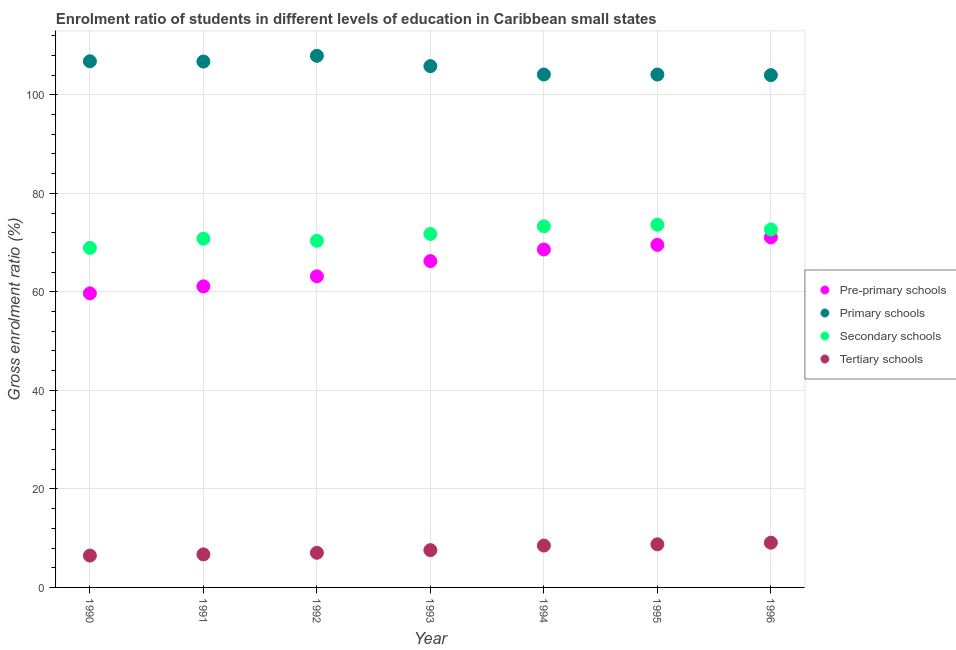Is the number of dotlines equal to the number of legend labels?
Your response must be concise. Yes. What is the gross enrolment ratio in primary schools in 1992?
Your response must be concise. 107.91. Across all years, what is the maximum gross enrolment ratio in tertiary schools?
Keep it short and to the point. 9.08. Across all years, what is the minimum gross enrolment ratio in pre-primary schools?
Your answer should be compact. 59.69. What is the total gross enrolment ratio in tertiary schools in the graph?
Give a very brief answer. 54.09. What is the difference between the gross enrolment ratio in tertiary schools in 1994 and that in 1995?
Make the answer very short. -0.26. What is the difference between the gross enrolment ratio in primary schools in 1990 and the gross enrolment ratio in secondary schools in 1993?
Provide a succinct answer. 35.05. What is the average gross enrolment ratio in pre-primary schools per year?
Offer a terse response. 65.63. In the year 1991, what is the difference between the gross enrolment ratio in pre-primary schools and gross enrolment ratio in primary schools?
Your answer should be compact. -45.63. In how many years, is the gross enrolment ratio in tertiary schools greater than 52 %?
Provide a succinct answer. 0. What is the ratio of the gross enrolment ratio in tertiary schools in 1990 to that in 1996?
Make the answer very short. 0.71. Is the difference between the gross enrolment ratio in pre-primary schools in 1993 and 1996 greater than the difference between the gross enrolment ratio in tertiary schools in 1993 and 1996?
Your answer should be very brief. No. What is the difference between the highest and the second highest gross enrolment ratio in pre-primary schools?
Ensure brevity in your answer.  1.51. What is the difference between the highest and the lowest gross enrolment ratio in tertiary schools?
Your answer should be compact. 2.62. In how many years, is the gross enrolment ratio in pre-primary schools greater than the average gross enrolment ratio in pre-primary schools taken over all years?
Ensure brevity in your answer.  4. Is it the case that in every year, the sum of the gross enrolment ratio in pre-primary schools and gross enrolment ratio in primary schools is greater than the gross enrolment ratio in secondary schools?
Your response must be concise. Yes. Is the gross enrolment ratio in tertiary schools strictly greater than the gross enrolment ratio in secondary schools over the years?
Offer a terse response. No. How many dotlines are there?
Your response must be concise. 4. How many years are there in the graph?
Offer a terse response. 7. Does the graph contain any zero values?
Your answer should be very brief. No. What is the title of the graph?
Make the answer very short. Enrolment ratio of students in different levels of education in Caribbean small states. Does "Switzerland" appear as one of the legend labels in the graph?
Keep it short and to the point. No. What is the label or title of the Y-axis?
Keep it short and to the point. Gross enrolment ratio (%). What is the Gross enrolment ratio (%) of Pre-primary schools in 1990?
Offer a terse response. 59.69. What is the Gross enrolment ratio (%) of Primary schools in 1990?
Your response must be concise. 106.8. What is the Gross enrolment ratio (%) in Secondary schools in 1990?
Your response must be concise. 68.92. What is the Gross enrolment ratio (%) of Tertiary schools in 1990?
Offer a very short reply. 6.46. What is the Gross enrolment ratio (%) of Pre-primary schools in 1991?
Ensure brevity in your answer.  61.12. What is the Gross enrolment ratio (%) in Primary schools in 1991?
Your answer should be very brief. 106.75. What is the Gross enrolment ratio (%) in Secondary schools in 1991?
Make the answer very short. 70.79. What is the Gross enrolment ratio (%) of Tertiary schools in 1991?
Ensure brevity in your answer.  6.71. What is the Gross enrolment ratio (%) of Pre-primary schools in 1992?
Give a very brief answer. 63.15. What is the Gross enrolment ratio (%) of Primary schools in 1992?
Provide a short and direct response. 107.91. What is the Gross enrolment ratio (%) in Secondary schools in 1992?
Offer a very short reply. 70.37. What is the Gross enrolment ratio (%) in Tertiary schools in 1992?
Make the answer very short. 7.03. What is the Gross enrolment ratio (%) of Pre-primary schools in 1993?
Keep it short and to the point. 66.24. What is the Gross enrolment ratio (%) of Primary schools in 1993?
Provide a succinct answer. 105.81. What is the Gross enrolment ratio (%) of Secondary schools in 1993?
Offer a terse response. 71.75. What is the Gross enrolment ratio (%) in Tertiary schools in 1993?
Make the answer very short. 7.57. What is the Gross enrolment ratio (%) in Pre-primary schools in 1994?
Offer a terse response. 68.6. What is the Gross enrolment ratio (%) of Primary schools in 1994?
Give a very brief answer. 104.12. What is the Gross enrolment ratio (%) in Secondary schools in 1994?
Ensure brevity in your answer.  73.3. What is the Gross enrolment ratio (%) in Tertiary schools in 1994?
Ensure brevity in your answer.  8.5. What is the Gross enrolment ratio (%) of Pre-primary schools in 1995?
Provide a short and direct response. 69.53. What is the Gross enrolment ratio (%) of Primary schools in 1995?
Provide a succinct answer. 104.11. What is the Gross enrolment ratio (%) in Secondary schools in 1995?
Your answer should be very brief. 73.62. What is the Gross enrolment ratio (%) of Tertiary schools in 1995?
Your answer should be very brief. 8.75. What is the Gross enrolment ratio (%) in Pre-primary schools in 1996?
Offer a very short reply. 71.05. What is the Gross enrolment ratio (%) in Primary schools in 1996?
Provide a short and direct response. 103.98. What is the Gross enrolment ratio (%) in Secondary schools in 1996?
Offer a terse response. 72.66. What is the Gross enrolment ratio (%) of Tertiary schools in 1996?
Give a very brief answer. 9.08. Across all years, what is the maximum Gross enrolment ratio (%) in Pre-primary schools?
Your answer should be compact. 71.05. Across all years, what is the maximum Gross enrolment ratio (%) in Primary schools?
Make the answer very short. 107.91. Across all years, what is the maximum Gross enrolment ratio (%) of Secondary schools?
Give a very brief answer. 73.62. Across all years, what is the maximum Gross enrolment ratio (%) of Tertiary schools?
Make the answer very short. 9.08. Across all years, what is the minimum Gross enrolment ratio (%) of Pre-primary schools?
Make the answer very short. 59.69. Across all years, what is the minimum Gross enrolment ratio (%) in Primary schools?
Your answer should be very brief. 103.98. Across all years, what is the minimum Gross enrolment ratio (%) in Secondary schools?
Your response must be concise. 68.92. Across all years, what is the minimum Gross enrolment ratio (%) in Tertiary schools?
Provide a succinct answer. 6.46. What is the total Gross enrolment ratio (%) of Pre-primary schools in the graph?
Provide a succinct answer. 459.38. What is the total Gross enrolment ratio (%) of Primary schools in the graph?
Ensure brevity in your answer.  739.47. What is the total Gross enrolment ratio (%) of Secondary schools in the graph?
Offer a very short reply. 501.4. What is the total Gross enrolment ratio (%) in Tertiary schools in the graph?
Your answer should be very brief. 54.09. What is the difference between the Gross enrolment ratio (%) in Pre-primary schools in 1990 and that in 1991?
Your answer should be very brief. -1.42. What is the difference between the Gross enrolment ratio (%) in Primary schools in 1990 and that in 1991?
Offer a terse response. 0.05. What is the difference between the Gross enrolment ratio (%) in Secondary schools in 1990 and that in 1991?
Your answer should be compact. -1.87. What is the difference between the Gross enrolment ratio (%) of Tertiary schools in 1990 and that in 1991?
Offer a terse response. -0.24. What is the difference between the Gross enrolment ratio (%) of Pre-primary schools in 1990 and that in 1992?
Offer a terse response. -3.46. What is the difference between the Gross enrolment ratio (%) in Primary schools in 1990 and that in 1992?
Your answer should be very brief. -1.11. What is the difference between the Gross enrolment ratio (%) of Secondary schools in 1990 and that in 1992?
Make the answer very short. -1.45. What is the difference between the Gross enrolment ratio (%) of Tertiary schools in 1990 and that in 1992?
Ensure brevity in your answer.  -0.57. What is the difference between the Gross enrolment ratio (%) of Pre-primary schools in 1990 and that in 1993?
Your answer should be compact. -6.55. What is the difference between the Gross enrolment ratio (%) of Secondary schools in 1990 and that in 1993?
Provide a succinct answer. -2.83. What is the difference between the Gross enrolment ratio (%) of Tertiary schools in 1990 and that in 1993?
Provide a succinct answer. -1.1. What is the difference between the Gross enrolment ratio (%) of Pre-primary schools in 1990 and that in 1994?
Provide a succinct answer. -8.91. What is the difference between the Gross enrolment ratio (%) in Primary schools in 1990 and that in 1994?
Keep it short and to the point. 2.68. What is the difference between the Gross enrolment ratio (%) of Secondary schools in 1990 and that in 1994?
Provide a succinct answer. -4.38. What is the difference between the Gross enrolment ratio (%) in Tertiary schools in 1990 and that in 1994?
Give a very brief answer. -2.03. What is the difference between the Gross enrolment ratio (%) of Pre-primary schools in 1990 and that in 1995?
Give a very brief answer. -9.84. What is the difference between the Gross enrolment ratio (%) of Primary schools in 1990 and that in 1995?
Keep it short and to the point. 2.69. What is the difference between the Gross enrolment ratio (%) of Secondary schools in 1990 and that in 1995?
Make the answer very short. -4.71. What is the difference between the Gross enrolment ratio (%) of Tertiary schools in 1990 and that in 1995?
Your answer should be very brief. -2.29. What is the difference between the Gross enrolment ratio (%) in Pre-primary schools in 1990 and that in 1996?
Your response must be concise. -11.36. What is the difference between the Gross enrolment ratio (%) of Primary schools in 1990 and that in 1996?
Your answer should be very brief. 2.82. What is the difference between the Gross enrolment ratio (%) in Secondary schools in 1990 and that in 1996?
Give a very brief answer. -3.74. What is the difference between the Gross enrolment ratio (%) of Tertiary schools in 1990 and that in 1996?
Your answer should be compact. -2.62. What is the difference between the Gross enrolment ratio (%) of Pre-primary schools in 1991 and that in 1992?
Offer a terse response. -2.04. What is the difference between the Gross enrolment ratio (%) in Primary schools in 1991 and that in 1992?
Provide a short and direct response. -1.16. What is the difference between the Gross enrolment ratio (%) of Secondary schools in 1991 and that in 1992?
Provide a short and direct response. 0.42. What is the difference between the Gross enrolment ratio (%) in Tertiary schools in 1991 and that in 1992?
Provide a short and direct response. -0.32. What is the difference between the Gross enrolment ratio (%) of Pre-primary schools in 1991 and that in 1993?
Provide a short and direct response. -5.13. What is the difference between the Gross enrolment ratio (%) of Primary schools in 1991 and that in 1993?
Your answer should be very brief. 0.93. What is the difference between the Gross enrolment ratio (%) in Secondary schools in 1991 and that in 1993?
Your response must be concise. -0.96. What is the difference between the Gross enrolment ratio (%) of Tertiary schools in 1991 and that in 1993?
Give a very brief answer. -0.86. What is the difference between the Gross enrolment ratio (%) of Pre-primary schools in 1991 and that in 1994?
Give a very brief answer. -7.48. What is the difference between the Gross enrolment ratio (%) of Primary schools in 1991 and that in 1994?
Make the answer very short. 2.63. What is the difference between the Gross enrolment ratio (%) in Secondary schools in 1991 and that in 1994?
Your answer should be compact. -2.51. What is the difference between the Gross enrolment ratio (%) in Tertiary schools in 1991 and that in 1994?
Provide a short and direct response. -1.79. What is the difference between the Gross enrolment ratio (%) of Pre-primary schools in 1991 and that in 1995?
Give a very brief answer. -8.42. What is the difference between the Gross enrolment ratio (%) of Primary schools in 1991 and that in 1995?
Offer a terse response. 2.64. What is the difference between the Gross enrolment ratio (%) of Secondary schools in 1991 and that in 1995?
Offer a very short reply. -2.83. What is the difference between the Gross enrolment ratio (%) of Tertiary schools in 1991 and that in 1995?
Ensure brevity in your answer.  -2.05. What is the difference between the Gross enrolment ratio (%) in Pre-primary schools in 1991 and that in 1996?
Offer a terse response. -9.93. What is the difference between the Gross enrolment ratio (%) of Primary schools in 1991 and that in 1996?
Make the answer very short. 2.76. What is the difference between the Gross enrolment ratio (%) of Secondary schools in 1991 and that in 1996?
Give a very brief answer. -1.87. What is the difference between the Gross enrolment ratio (%) of Tertiary schools in 1991 and that in 1996?
Keep it short and to the point. -2.37. What is the difference between the Gross enrolment ratio (%) in Pre-primary schools in 1992 and that in 1993?
Give a very brief answer. -3.09. What is the difference between the Gross enrolment ratio (%) in Primary schools in 1992 and that in 1993?
Make the answer very short. 2.09. What is the difference between the Gross enrolment ratio (%) of Secondary schools in 1992 and that in 1993?
Your answer should be very brief. -1.38. What is the difference between the Gross enrolment ratio (%) of Tertiary schools in 1992 and that in 1993?
Make the answer very short. -0.54. What is the difference between the Gross enrolment ratio (%) of Pre-primary schools in 1992 and that in 1994?
Ensure brevity in your answer.  -5.45. What is the difference between the Gross enrolment ratio (%) in Primary schools in 1992 and that in 1994?
Provide a short and direct response. 3.79. What is the difference between the Gross enrolment ratio (%) in Secondary schools in 1992 and that in 1994?
Offer a very short reply. -2.93. What is the difference between the Gross enrolment ratio (%) of Tertiary schools in 1992 and that in 1994?
Provide a succinct answer. -1.47. What is the difference between the Gross enrolment ratio (%) of Pre-primary schools in 1992 and that in 1995?
Your answer should be compact. -6.38. What is the difference between the Gross enrolment ratio (%) in Primary schools in 1992 and that in 1995?
Provide a short and direct response. 3.8. What is the difference between the Gross enrolment ratio (%) in Secondary schools in 1992 and that in 1995?
Your response must be concise. -3.26. What is the difference between the Gross enrolment ratio (%) of Tertiary schools in 1992 and that in 1995?
Your answer should be compact. -1.72. What is the difference between the Gross enrolment ratio (%) of Pre-primary schools in 1992 and that in 1996?
Your response must be concise. -7.9. What is the difference between the Gross enrolment ratio (%) in Primary schools in 1992 and that in 1996?
Give a very brief answer. 3.93. What is the difference between the Gross enrolment ratio (%) of Secondary schools in 1992 and that in 1996?
Your answer should be very brief. -2.29. What is the difference between the Gross enrolment ratio (%) in Tertiary schools in 1992 and that in 1996?
Ensure brevity in your answer.  -2.05. What is the difference between the Gross enrolment ratio (%) in Pre-primary schools in 1993 and that in 1994?
Make the answer very short. -2.36. What is the difference between the Gross enrolment ratio (%) in Primary schools in 1993 and that in 1994?
Provide a succinct answer. 1.7. What is the difference between the Gross enrolment ratio (%) in Secondary schools in 1993 and that in 1994?
Provide a short and direct response. -1.55. What is the difference between the Gross enrolment ratio (%) of Tertiary schools in 1993 and that in 1994?
Your response must be concise. -0.93. What is the difference between the Gross enrolment ratio (%) in Pre-primary schools in 1993 and that in 1995?
Give a very brief answer. -3.29. What is the difference between the Gross enrolment ratio (%) in Primary schools in 1993 and that in 1995?
Ensure brevity in your answer.  1.71. What is the difference between the Gross enrolment ratio (%) in Secondary schools in 1993 and that in 1995?
Your answer should be compact. -1.88. What is the difference between the Gross enrolment ratio (%) in Tertiary schools in 1993 and that in 1995?
Your answer should be compact. -1.19. What is the difference between the Gross enrolment ratio (%) of Pre-primary schools in 1993 and that in 1996?
Ensure brevity in your answer.  -4.81. What is the difference between the Gross enrolment ratio (%) in Primary schools in 1993 and that in 1996?
Your response must be concise. 1.83. What is the difference between the Gross enrolment ratio (%) of Secondary schools in 1993 and that in 1996?
Offer a terse response. -0.91. What is the difference between the Gross enrolment ratio (%) of Tertiary schools in 1993 and that in 1996?
Provide a succinct answer. -1.51. What is the difference between the Gross enrolment ratio (%) of Pre-primary schools in 1994 and that in 1995?
Offer a very short reply. -0.93. What is the difference between the Gross enrolment ratio (%) of Primary schools in 1994 and that in 1995?
Your answer should be very brief. 0.01. What is the difference between the Gross enrolment ratio (%) of Secondary schools in 1994 and that in 1995?
Your answer should be compact. -0.33. What is the difference between the Gross enrolment ratio (%) in Tertiary schools in 1994 and that in 1995?
Provide a succinct answer. -0.26. What is the difference between the Gross enrolment ratio (%) of Pre-primary schools in 1994 and that in 1996?
Provide a succinct answer. -2.45. What is the difference between the Gross enrolment ratio (%) in Primary schools in 1994 and that in 1996?
Your answer should be very brief. 0.13. What is the difference between the Gross enrolment ratio (%) in Secondary schools in 1994 and that in 1996?
Give a very brief answer. 0.64. What is the difference between the Gross enrolment ratio (%) in Tertiary schools in 1994 and that in 1996?
Provide a short and direct response. -0.58. What is the difference between the Gross enrolment ratio (%) of Pre-primary schools in 1995 and that in 1996?
Make the answer very short. -1.51. What is the difference between the Gross enrolment ratio (%) in Primary schools in 1995 and that in 1996?
Keep it short and to the point. 0.12. What is the difference between the Gross enrolment ratio (%) in Secondary schools in 1995 and that in 1996?
Provide a succinct answer. 0.97. What is the difference between the Gross enrolment ratio (%) of Tertiary schools in 1995 and that in 1996?
Your answer should be compact. -0.33. What is the difference between the Gross enrolment ratio (%) in Pre-primary schools in 1990 and the Gross enrolment ratio (%) in Primary schools in 1991?
Your answer should be very brief. -47.05. What is the difference between the Gross enrolment ratio (%) in Pre-primary schools in 1990 and the Gross enrolment ratio (%) in Secondary schools in 1991?
Offer a very short reply. -11.1. What is the difference between the Gross enrolment ratio (%) of Pre-primary schools in 1990 and the Gross enrolment ratio (%) of Tertiary schools in 1991?
Make the answer very short. 52.99. What is the difference between the Gross enrolment ratio (%) of Primary schools in 1990 and the Gross enrolment ratio (%) of Secondary schools in 1991?
Make the answer very short. 36.01. What is the difference between the Gross enrolment ratio (%) in Primary schools in 1990 and the Gross enrolment ratio (%) in Tertiary schools in 1991?
Your answer should be very brief. 100.09. What is the difference between the Gross enrolment ratio (%) in Secondary schools in 1990 and the Gross enrolment ratio (%) in Tertiary schools in 1991?
Offer a very short reply. 62.21. What is the difference between the Gross enrolment ratio (%) in Pre-primary schools in 1990 and the Gross enrolment ratio (%) in Primary schools in 1992?
Provide a succinct answer. -48.22. What is the difference between the Gross enrolment ratio (%) in Pre-primary schools in 1990 and the Gross enrolment ratio (%) in Secondary schools in 1992?
Your response must be concise. -10.67. What is the difference between the Gross enrolment ratio (%) of Pre-primary schools in 1990 and the Gross enrolment ratio (%) of Tertiary schools in 1992?
Keep it short and to the point. 52.66. What is the difference between the Gross enrolment ratio (%) of Primary schools in 1990 and the Gross enrolment ratio (%) of Secondary schools in 1992?
Provide a succinct answer. 36.43. What is the difference between the Gross enrolment ratio (%) in Primary schools in 1990 and the Gross enrolment ratio (%) in Tertiary schools in 1992?
Provide a short and direct response. 99.77. What is the difference between the Gross enrolment ratio (%) of Secondary schools in 1990 and the Gross enrolment ratio (%) of Tertiary schools in 1992?
Give a very brief answer. 61.89. What is the difference between the Gross enrolment ratio (%) in Pre-primary schools in 1990 and the Gross enrolment ratio (%) in Primary schools in 1993?
Provide a short and direct response. -46.12. What is the difference between the Gross enrolment ratio (%) of Pre-primary schools in 1990 and the Gross enrolment ratio (%) of Secondary schools in 1993?
Your answer should be compact. -12.05. What is the difference between the Gross enrolment ratio (%) of Pre-primary schools in 1990 and the Gross enrolment ratio (%) of Tertiary schools in 1993?
Offer a very short reply. 52.12. What is the difference between the Gross enrolment ratio (%) in Primary schools in 1990 and the Gross enrolment ratio (%) in Secondary schools in 1993?
Your answer should be very brief. 35.05. What is the difference between the Gross enrolment ratio (%) of Primary schools in 1990 and the Gross enrolment ratio (%) of Tertiary schools in 1993?
Keep it short and to the point. 99.23. What is the difference between the Gross enrolment ratio (%) of Secondary schools in 1990 and the Gross enrolment ratio (%) of Tertiary schools in 1993?
Offer a terse response. 61.35. What is the difference between the Gross enrolment ratio (%) of Pre-primary schools in 1990 and the Gross enrolment ratio (%) of Primary schools in 1994?
Provide a short and direct response. -44.42. What is the difference between the Gross enrolment ratio (%) of Pre-primary schools in 1990 and the Gross enrolment ratio (%) of Secondary schools in 1994?
Your answer should be compact. -13.61. What is the difference between the Gross enrolment ratio (%) of Pre-primary schools in 1990 and the Gross enrolment ratio (%) of Tertiary schools in 1994?
Offer a terse response. 51.2. What is the difference between the Gross enrolment ratio (%) in Primary schools in 1990 and the Gross enrolment ratio (%) in Secondary schools in 1994?
Offer a terse response. 33.5. What is the difference between the Gross enrolment ratio (%) in Primary schools in 1990 and the Gross enrolment ratio (%) in Tertiary schools in 1994?
Your response must be concise. 98.3. What is the difference between the Gross enrolment ratio (%) in Secondary schools in 1990 and the Gross enrolment ratio (%) in Tertiary schools in 1994?
Keep it short and to the point. 60.42. What is the difference between the Gross enrolment ratio (%) of Pre-primary schools in 1990 and the Gross enrolment ratio (%) of Primary schools in 1995?
Make the answer very short. -44.41. What is the difference between the Gross enrolment ratio (%) in Pre-primary schools in 1990 and the Gross enrolment ratio (%) in Secondary schools in 1995?
Give a very brief answer. -13.93. What is the difference between the Gross enrolment ratio (%) in Pre-primary schools in 1990 and the Gross enrolment ratio (%) in Tertiary schools in 1995?
Your answer should be compact. 50.94. What is the difference between the Gross enrolment ratio (%) of Primary schools in 1990 and the Gross enrolment ratio (%) of Secondary schools in 1995?
Ensure brevity in your answer.  33.17. What is the difference between the Gross enrolment ratio (%) of Primary schools in 1990 and the Gross enrolment ratio (%) of Tertiary schools in 1995?
Give a very brief answer. 98.05. What is the difference between the Gross enrolment ratio (%) in Secondary schools in 1990 and the Gross enrolment ratio (%) in Tertiary schools in 1995?
Give a very brief answer. 60.16. What is the difference between the Gross enrolment ratio (%) in Pre-primary schools in 1990 and the Gross enrolment ratio (%) in Primary schools in 1996?
Provide a short and direct response. -44.29. What is the difference between the Gross enrolment ratio (%) of Pre-primary schools in 1990 and the Gross enrolment ratio (%) of Secondary schools in 1996?
Ensure brevity in your answer.  -12.96. What is the difference between the Gross enrolment ratio (%) in Pre-primary schools in 1990 and the Gross enrolment ratio (%) in Tertiary schools in 1996?
Give a very brief answer. 50.61. What is the difference between the Gross enrolment ratio (%) of Primary schools in 1990 and the Gross enrolment ratio (%) of Secondary schools in 1996?
Offer a very short reply. 34.14. What is the difference between the Gross enrolment ratio (%) in Primary schools in 1990 and the Gross enrolment ratio (%) in Tertiary schools in 1996?
Provide a succinct answer. 97.72. What is the difference between the Gross enrolment ratio (%) in Secondary schools in 1990 and the Gross enrolment ratio (%) in Tertiary schools in 1996?
Keep it short and to the point. 59.84. What is the difference between the Gross enrolment ratio (%) of Pre-primary schools in 1991 and the Gross enrolment ratio (%) of Primary schools in 1992?
Provide a succinct answer. -46.79. What is the difference between the Gross enrolment ratio (%) in Pre-primary schools in 1991 and the Gross enrolment ratio (%) in Secondary schools in 1992?
Your answer should be compact. -9.25. What is the difference between the Gross enrolment ratio (%) in Pre-primary schools in 1991 and the Gross enrolment ratio (%) in Tertiary schools in 1992?
Your answer should be very brief. 54.09. What is the difference between the Gross enrolment ratio (%) of Primary schools in 1991 and the Gross enrolment ratio (%) of Secondary schools in 1992?
Make the answer very short. 36.38. What is the difference between the Gross enrolment ratio (%) of Primary schools in 1991 and the Gross enrolment ratio (%) of Tertiary schools in 1992?
Your answer should be compact. 99.72. What is the difference between the Gross enrolment ratio (%) of Secondary schools in 1991 and the Gross enrolment ratio (%) of Tertiary schools in 1992?
Keep it short and to the point. 63.76. What is the difference between the Gross enrolment ratio (%) in Pre-primary schools in 1991 and the Gross enrolment ratio (%) in Primary schools in 1993?
Offer a terse response. -44.7. What is the difference between the Gross enrolment ratio (%) in Pre-primary schools in 1991 and the Gross enrolment ratio (%) in Secondary schools in 1993?
Your answer should be compact. -10.63. What is the difference between the Gross enrolment ratio (%) of Pre-primary schools in 1991 and the Gross enrolment ratio (%) of Tertiary schools in 1993?
Ensure brevity in your answer.  53.55. What is the difference between the Gross enrolment ratio (%) of Primary schools in 1991 and the Gross enrolment ratio (%) of Secondary schools in 1993?
Offer a terse response. 35. What is the difference between the Gross enrolment ratio (%) in Primary schools in 1991 and the Gross enrolment ratio (%) in Tertiary schools in 1993?
Your response must be concise. 99.18. What is the difference between the Gross enrolment ratio (%) in Secondary schools in 1991 and the Gross enrolment ratio (%) in Tertiary schools in 1993?
Make the answer very short. 63.22. What is the difference between the Gross enrolment ratio (%) of Pre-primary schools in 1991 and the Gross enrolment ratio (%) of Primary schools in 1994?
Offer a terse response. -43. What is the difference between the Gross enrolment ratio (%) in Pre-primary schools in 1991 and the Gross enrolment ratio (%) in Secondary schools in 1994?
Offer a very short reply. -12.18. What is the difference between the Gross enrolment ratio (%) in Pre-primary schools in 1991 and the Gross enrolment ratio (%) in Tertiary schools in 1994?
Offer a very short reply. 52.62. What is the difference between the Gross enrolment ratio (%) of Primary schools in 1991 and the Gross enrolment ratio (%) of Secondary schools in 1994?
Offer a very short reply. 33.45. What is the difference between the Gross enrolment ratio (%) in Primary schools in 1991 and the Gross enrolment ratio (%) in Tertiary schools in 1994?
Your response must be concise. 98.25. What is the difference between the Gross enrolment ratio (%) of Secondary schools in 1991 and the Gross enrolment ratio (%) of Tertiary schools in 1994?
Provide a succinct answer. 62.29. What is the difference between the Gross enrolment ratio (%) of Pre-primary schools in 1991 and the Gross enrolment ratio (%) of Primary schools in 1995?
Your answer should be very brief. -42.99. What is the difference between the Gross enrolment ratio (%) in Pre-primary schools in 1991 and the Gross enrolment ratio (%) in Secondary schools in 1995?
Ensure brevity in your answer.  -12.51. What is the difference between the Gross enrolment ratio (%) of Pre-primary schools in 1991 and the Gross enrolment ratio (%) of Tertiary schools in 1995?
Your response must be concise. 52.36. What is the difference between the Gross enrolment ratio (%) of Primary schools in 1991 and the Gross enrolment ratio (%) of Secondary schools in 1995?
Provide a succinct answer. 33.12. What is the difference between the Gross enrolment ratio (%) in Primary schools in 1991 and the Gross enrolment ratio (%) in Tertiary schools in 1995?
Your answer should be very brief. 97.99. What is the difference between the Gross enrolment ratio (%) in Secondary schools in 1991 and the Gross enrolment ratio (%) in Tertiary schools in 1995?
Offer a terse response. 62.04. What is the difference between the Gross enrolment ratio (%) in Pre-primary schools in 1991 and the Gross enrolment ratio (%) in Primary schools in 1996?
Your response must be concise. -42.87. What is the difference between the Gross enrolment ratio (%) of Pre-primary schools in 1991 and the Gross enrolment ratio (%) of Secondary schools in 1996?
Offer a terse response. -11.54. What is the difference between the Gross enrolment ratio (%) in Pre-primary schools in 1991 and the Gross enrolment ratio (%) in Tertiary schools in 1996?
Provide a succinct answer. 52.04. What is the difference between the Gross enrolment ratio (%) of Primary schools in 1991 and the Gross enrolment ratio (%) of Secondary schools in 1996?
Make the answer very short. 34.09. What is the difference between the Gross enrolment ratio (%) in Primary schools in 1991 and the Gross enrolment ratio (%) in Tertiary schools in 1996?
Keep it short and to the point. 97.67. What is the difference between the Gross enrolment ratio (%) of Secondary schools in 1991 and the Gross enrolment ratio (%) of Tertiary schools in 1996?
Ensure brevity in your answer.  61.71. What is the difference between the Gross enrolment ratio (%) of Pre-primary schools in 1992 and the Gross enrolment ratio (%) of Primary schools in 1993?
Offer a very short reply. -42.66. What is the difference between the Gross enrolment ratio (%) in Pre-primary schools in 1992 and the Gross enrolment ratio (%) in Secondary schools in 1993?
Offer a terse response. -8.59. What is the difference between the Gross enrolment ratio (%) in Pre-primary schools in 1992 and the Gross enrolment ratio (%) in Tertiary schools in 1993?
Ensure brevity in your answer.  55.58. What is the difference between the Gross enrolment ratio (%) of Primary schools in 1992 and the Gross enrolment ratio (%) of Secondary schools in 1993?
Your response must be concise. 36.16. What is the difference between the Gross enrolment ratio (%) in Primary schools in 1992 and the Gross enrolment ratio (%) in Tertiary schools in 1993?
Offer a very short reply. 100.34. What is the difference between the Gross enrolment ratio (%) of Secondary schools in 1992 and the Gross enrolment ratio (%) of Tertiary schools in 1993?
Your answer should be compact. 62.8. What is the difference between the Gross enrolment ratio (%) in Pre-primary schools in 1992 and the Gross enrolment ratio (%) in Primary schools in 1994?
Provide a succinct answer. -40.97. What is the difference between the Gross enrolment ratio (%) of Pre-primary schools in 1992 and the Gross enrolment ratio (%) of Secondary schools in 1994?
Offer a very short reply. -10.15. What is the difference between the Gross enrolment ratio (%) of Pre-primary schools in 1992 and the Gross enrolment ratio (%) of Tertiary schools in 1994?
Provide a succinct answer. 54.65. What is the difference between the Gross enrolment ratio (%) of Primary schools in 1992 and the Gross enrolment ratio (%) of Secondary schools in 1994?
Your answer should be very brief. 34.61. What is the difference between the Gross enrolment ratio (%) of Primary schools in 1992 and the Gross enrolment ratio (%) of Tertiary schools in 1994?
Provide a short and direct response. 99.41. What is the difference between the Gross enrolment ratio (%) in Secondary schools in 1992 and the Gross enrolment ratio (%) in Tertiary schools in 1994?
Ensure brevity in your answer.  61.87. What is the difference between the Gross enrolment ratio (%) in Pre-primary schools in 1992 and the Gross enrolment ratio (%) in Primary schools in 1995?
Give a very brief answer. -40.95. What is the difference between the Gross enrolment ratio (%) of Pre-primary schools in 1992 and the Gross enrolment ratio (%) of Secondary schools in 1995?
Provide a succinct answer. -10.47. What is the difference between the Gross enrolment ratio (%) of Pre-primary schools in 1992 and the Gross enrolment ratio (%) of Tertiary schools in 1995?
Offer a very short reply. 54.4. What is the difference between the Gross enrolment ratio (%) in Primary schools in 1992 and the Gross enrolment ratio (%) in Secondary schools in 1995?
Your answer should be compact. 34.28. What is the difference between the Gross enrolment ratio (%) in Primary schools in 1992 and the Gross enrolment ratio (%) in Tertiary schools in 1995?
Offer a very short reply. 99.16. What is the difference between the Gross enrolment ratio (%) of Secondary schools in 1992 and the Gross enrolment ratio (%) of Tertiary schools in 1995?
Your response must be concise. 61.61. What is the difference between the Gross enrolment ratio (%) in Pre-primary schools in 1992 and the Gross enrolment ratio (%) in Primary schools in 1996?
Your answer should be compact. -40.83. What is the difference between the Gross enrolment ratio (%) in Pre-primary schools in 1992 and the Gross enrolment ratio (%) in Secondary schools in 1996?
Keep it short and to the point. -9.51. What is the difference between the Gross enrolment ratio (%) of Pre-primary schools in 1992 and the Gross enrolment ratio (%) of Tertiary schools in 1996?
Provide a short and direct response. 54.07. What is the difference between the Gross enrolment ratio (%) of Primary schools in 1992 and the Gross enrolment ratio (%) of Secondary schools in 1996?
Keep it short and to the point. 35.25. What is the difference between the Gross enrolment ratio (%) in Primary schools in 1992 and the Gross enrolment ratio (%) in Tertiary schools in 1996?
Keep it short and to the point. 98.83. What is the difference between the Gross enrolment ratio (%) of Secondary schools in 1992 and the Gross enrolment ratio (%) of Tertiary schools in 1996?
Give a very brief answer. 61.29. What is the difference between the Gross enrolment ratio (%) of Pre-primary schools in 1993 and the Gross enrolment ratio (%) of Primary schools in 1994?
Keep it short and to the point. -37.87. What is the difference between the Gross enrolment ratio (%) of Pre-primary schools in 1993 and the Gross enrolment ratio (%) of Secondary schools in 1994?
Your answer should be compact. -7.06. What is the difference between the Gross enrolment ratio (%) in Pre-primary schools in 1993 and the Gross enrolment ratio (%) in Tertiary schools in 1994?
Keep it short and to the point. 57.74. What is the difference between the Gross enrolment ratio (%) of Primary schools in 1993 and the Gross enrolment ratio (%) of Secondary schools in 1994?
Provide a succinct answer. 32.52. What is the difference between the Gross enrolment ratio (%) in Primary schools in 1993 and the Gross enrolment ratio (%) in Tertiary schools in 1994?
Your answer should be very brief. 97.32. What is the difference between the Gross enrolment ratio (%) in Secondary schools in 1993 and the Gross enrolment ratio (%) in Tertiary schools in 1994?
Keep it short and to the point. 63.25. What is the difference between the Gross enrolment ratio (%) of Pre-primary schools in 1993 and the Gross enrolment ratio (%) of Primary schools in 1995?
Make the answer very short. -37.86. What is the difference between the Gross enrolment ratio (%) in Pre-primary schools in 1993 and the Gross enrolment ratio (%) in Secondary schools in 1995?
Keep it short and to the point. -7.38. What is the difference between the Gross enrolment ratio (%) in Pre-primary schools in 1993 and the Gross enrolment ratio (%) in Tertiary schools in 1995?
Keep it short and to the point. 57.49. What is the difference between the Gross enrolment ratio (%) in Primary schools in 1993 and the Gross enrolment ratio (%) in Secondary schools in 1995?
Your answer should be compact. 32.19. What is the difference between the Gross enrolment ratio (%) of Primary schools in 1993 and the Gross enrolment ratio (%) of Tertiary schools in 1995?
Make the answer very short. 97.06. What is the difference between the Gross enrolment ratio (%) in Secondary schools in 1993 and the Gross enrolment ratio (%) in Tertiary schools in 1995?
Your answer should be very brief. 62.99. What is the difference between the Gross enrolment ratio (%) in Pre-primary schools in 1993 and the Gross enrolment ratio (%) in Primary schools in 1996?
Provide a short and direct response. -37.74. What is the difference between the Gross enrolment ratio (%) in Pre-primary schools in 1993 and the Gross enrolment ratio (%) in Secondary schools in 1996?
Provide a short and direct response. -6.41. What is the difference between the Gross enrolment ratio (%) in Pre-primary schools in 1993 and the Gross enrolment ratio (%) in Tertiary schools in 1996?
Ensure brevity in your answer.  57.16. What is the difference between the Gross enrolment ratio (%) in Primary schools in 1993 and the Gross enrolment ratio (%) in Secondary schools in 1996?
Provide a short and direct response. 33.16. What is the difference between the Gross enrolment ratio (%) of Primary schools in 1993 and the Gross enrolment ratio (%) of Tertiary schools in 1996?
Your response must be concise. 96.74. What is the difference between the Gross enrolment ratio (%) in Secondary schools in 1993 and the Gross enrolment ratio (%) in Tertiary schools in 1996?
Ensure brevity in your answer.  62.67. What is the difference between the Gross enrolment ratio (%) in Pre-primary schools in 1994 and the Gross enrolment ratio (%) in Primary schools in 1995?
Your response must be concise. -35.51. What is the difference between the Gross enrolment ratio (%) in Pre-primary schools in 1994 and the Gross enrolment ratio (%) in Secondary schools in 1995?
Give a very brief answer. -5.03. What is the difference between the Gross enrolment ratio (%) in Pre-primary schools in 1994 and the Gross enrolment ratio (%) in Tertiary schools in 1995?
Keep it short and to the point. 59.85. What is the difference between the Gross enrolment ratio (%) in Primary schools in 1994 and the Gross enrolment ratio (%) in Secondary schools in 1995?
Make the answer very short. 30.49. What is the difference between the Gross enrolment ratio (%) in Primary schools in 1994 and the Gross enrolment ratio (%) in Tertiary schools in 1995?
Offer a terse response. 95.36. What is the difference between the Gross enrolment ratio (%) in Secondary schools in 1994 and the Gross enrolment ratio (%) in Tertiary schools in 1995?
Ensure brevity in your answer.  64.55. What is the difference between the Gross enrolment ratio (%) of Pre-primary schools in 1994 and the Gross enrolment ratio (%) of Primary schools in 1996?
Ensure brevity in your answer.  -35.38. What is the difference between the Gross enrolment ratio (%) in Pre-primary schools in 1994 and the Gross enrolment ratio (%) in Secondary schools in 1996?
Make the answer very short. -4.06. What is the difference between the Gross enrolment ratio (%) of Pre-primary schools in 1994 and the Gross enrolment ratio (%) of Tertiary schools in 1996?
Your response must be concise. 59.52. What is the difference between the Gross enrolment ratio (%) in Primary schools in 1994 and the Gross enrolment ratio (%) in Secondary schools in 1996?
Provide a short and direct response. 31.46. What is the difference between the Gross enrolment ratio (%) of Primary schools in 1994 and the Gross enrolment ratio (%) of Tertiary schools in 1996?
Make the answer very short. 95.04. What is the difference between the Gross enrolment ratio (%) of Secondary schools in 1994 and the Gross enrolment ratio (%) of Tertiary schools in 1996?
Keep it short and to the point. 64.22. What is the difference between the Gross enrolment ratio (%) of Pre-primary schools in 1995 and the Gross enrolment ratio (%) of Primary schools in 1996?
Your response must be concise. -34.45. What is the difference between the Gross enrolment ratio (%) of Pre-primary schools in 1995 and the Gross enrolment ratio (%) of Secondary schools in 1996?
Ensure brevity in your answer.  -3.12. What is the difference between the Gross enrolment ratio (%) in Pre-primary schools in 1995 and the Gross enrolment ratio (%) in Tertiary schools in 1996?
Your response must be concise. 60.45. What is the difference between the Gross enrolment ratio (%) of Primary schools in 1995 and the Gross enrolment ratio (%) of Secondary schools in 1996?
Keep it short and to the point. 31.45. What is the difference between the Gross enrolment ratio (%) in Primary schools in 1995 and the Gross enrolment ratio (%) in Tertiary schools in 1996?
Make the answer very short. 95.03. What is the difference between the Gross enrolment ratio (%) in Secondary schools in 1995 and the Gross enrolment ratio (%) in Tertiary schools in 1996?
Provide a short and direct response. 64.55. What is the average Gross enrolment ratio (%) of Pre-primary schools per year?
Keep it short and to the point. 65.63. What is the average Gross enrolment ratio (%) in Primary schools per year?
Your answer should be very brief. 105.64. What is the average Gross enrolment ratio (%) of Secondary schools per year?
Offer a very short reply. 71.63. What is the average Gross enrolment ratio (%) of Tertiary schools per year?
Your answer should be compact. 7.73. In the year 1990, what is the difference between the Gross enrolment ratio (%) of Pre-primary schools and Gross enrolment ratio (%) of Primary schools?
Your response must be concise. -47.11. In the year 1990, what is the difference between the Gross enrolment ratio (%) in Pre-primary schools and Gross enrolment ratio (%) in Secondary schools?
Your response must be concise. -9.22. In the year 1990, what is the difference between the Gross enrolment ratio (%) in Pre-primary schools and Gross enrolment ratio (%) in Tertiary schools?
Ensure brevity in your answer.  53.23. In the year 1990, what is the difference between the Gross enrolment ratio (%) in Primary schools and Gross enrolment ratio (%) in Secondary schools?
Ensure brevity in your answer.  37.88. In the year 1990, what is the difference between the Gross enrolment ratio (%) in Primary schools and Gross enrolment ratio (%) in Tertiary schools?
Give a very brief answer. 100.34. In the year 1990, what is the difference between the Gross enrolment ratio (%) in Secondary schools and Gross enrolment ratio (%) in Tertiary schools?
Provide a succinct answer. 62.45. In the year 1991, what is the difference between the Gross enrolment ratio (%) in Pre-primary schools and Gross enrolment ratio (%) in Primary schools?
Offer a terse response. -45.63. In the year 1991, what is the difference between the Gross enrolment ratio (%) of Pre-primary schools and Gross enrolment ratio (%) of Secondary schools?
Provide a short and direct response. -9.67. In the year 1991, what is the difference between the Gross enrolment ratio (%) in Pre-primary schools and Gross enrolment ratio (%) in Tertiary schools?
Your answer should be very brief. 54.41. In the year 1991, what is the difference between the Gross enrolment ratio (%) of Primary schools and Gross enrolment ratio (%) of Secondary schools?
Your response must be concise. 35.96. In the year 1991, what is the difference between the Gross enrolment ratio (%) in Primary schools and Gross enrolment ratio (%) in Tertiary schools?
Give a very brief answer. 100.04. In the year 1991, what is the difference between the Gross enrolment ratio (%) in Secondary schools and Gross enrolment ratio (%) in Tertiary schools?
Make the answer very short. 64.08. In the year 1992, what is the difference between the Gross enrolment ratio (%) of Pre-primary schools and Gross enrolment ratio (%) of Primary schools?
Give a very brief answer. -44.76. In the year 1992, what is the difference between the Gross enrolment ratio (%) in Pre-primary schools and Gross enrolment ratio (%) in Secondary schools?
Ensure brevity in your answer.  -7.22. In the year 1992, what is the difference between the Gross enrolment ratio (%) of Pre-primary schools and Gross enrolment ratio (%) of Tertiary schools?
Offer a terse response. 56.12. In the year 1992, what is the difference between the Gross enrolment ratio (%) of Primary schools and Gross enrolment ratio (%) of Secondary schools?
Provide a succinct answer. 37.54. In the year 1992, what is the difference between the Gross enrolment ratio (%) of Primary schools and Gross enrolment ratio (%) of Tertiary schools?
Your response must be concise. 100.88. In the year 1992, what is the difference between the Gross enrolment ratio (%) of Secondary schools and Gross enrolment ratio (%) of Tertiary schools?
Your answer should be compact. 63.34. In the year 1993, what is the difference between the Gross enrolment ratio (%) of Pre-primary schools and Gross enrolment ratio (%) of Primary schools?
Ensure brevity in your answer.  -39.57. In the year 1993, what is the difference between the Gross enrolment ratio (%) in Pre-primary schools and Gross enrolment ratio (%) in Secondary schools?
Make the answer very short. -5.5. In the year 1993, what is the difference between the Gross enrolment ratio (%) in Pre-primary schools and Gross enrolment ratio (%) in Tertiary schools?
Your answer should be compact. 58.67. In the year 1993, what is the difference between the Gross enrolment ratio (%) in Primary schools and Gross enrolment ratio (%) in Secondary schools?
Your response must be concise. 34.07. In the year 1993, what is the difference between the Gross enrolment ratio (%) in Primary schools and Gross enrolment ratio (%) in Tertiary schools?
Your response must be concise. 98.25. In the year 1993, what is the difference between the Gross enrolment ratio (%) of Secondary schools and Gross enrolment ratio (%) of Tertiary schools?
Make the answer very short. 64.18. In the year 1994, what is the difference between the Gross enrolment ratio (%) in Pre-primary schools and Gross enrolment ratio (%) in Primary schools?
Make the answer very short. -35.52. In the year 1994, what is the difference between the Gross enrolment ratio (%) of Pre-primary schools and Gross enrolment ratio (%) of Secondary schools?
Your response must be concise. -4.7. In the year 1994, what is the difference between the Gross enrolment ratio (%) of Pre-primary schools and Gross enrolment ratio (%) of Tertiary schools?
Your response must be concise. 60.1. In the year 1994, what is the difference between the Gross enrolment ratio (%) in Primary schools and Gross enrolment ratio (%) in Secondary schools?
Keep it short and to the point. 30.82. In the year 1994, what is the difference between the Gross enrolment ratio (%) in Primary schools and Gross enrolment ratio (%) in Tertiary schools?
Keep it short and to the point. 95.62. In the year 1994, what is the difference between the Gross enrolment ratio (%) in Secondary schools and Gross enrolment ratio (%) in Tertiary schools?
Your response must be concise. 64.8. In the year 1995, what is the difference between the Gross enrolment ratio (%) in Pre-primary schools and Gross enrolment ratio (%) in Primary schools?
Offer a terse response. -34.57. In the year 1995, what is the difference between the Gross enrolment ratio (%) in Pre-primary schools and Gross enrolment ratio (%) in Secondary schools?
Your answer should be very brief. -4.09. In the year 1995, what is the difference between the Gross enrolment ratio (%) in Pre-primary schools and Gross enrolment ratio (%) in Tertiary schools?
Your answer should be very brief. 60.78. In the year 1995, what is the difference between the Gross enrolment ratio (%) in Primary schools and Gross enrolment ratio (%) in Secondary schools?
Offer a terse response. 30.48. In the year 1995, what is the difference between the Gross enrolment ratio (%) in Primary schools and Gross enrolment ratio (%) in Tertiary schools?
Your answer should be compact. 95.35. In the year 1995, what is the difference between the Gross enrolment ratio (%) in Secondary schools and Gross enrolment ratio (%) in Tertiary schools?
Offer a very short reply. 64.87. In the year 1996, what is the difference between the Gross enrolment ratio (%) of Pre-primary schools and Gross enrolment ratio (%) of Primary schools?
Offer a very short reply. -32.93. In the year 1996, what is the difference between the Gross enrolment ratio (%) in Pre-primary schools and Gross enrolment ratio (%) in Secondary schools?
Your response must be concise. -1.61. In the year 1996, what is the difference between the Gross enrolment ratio (%) of Pre-primary schools and Gross enrolment ratio (%) of Tertiary schools?
Your response must be concise. 61.97. In the year 1996, what is the difference between the Gross enrolment ratio (%) of Primary schools and Gross enrolment ratio (%) of Secondary schools?
Your answer should be compact. 31.33. In the year 1996, what is the difference between the Gross enrolment ratio (%) of Primary schools and Gross enrolment ratio (%) of Tertiary schools?
Provide a succinct answer. 94.9. In the year 1996, what is the difference between the Gross enrolment ratio (%) of Secondary schools and Gross enrolment ratio (%) of Tertiary schools?
Ensure brevity in your answer.  63.58. What is the ratio of the Gross enrolment ratio (%) in Pre-primary schools in 1990 to that in 1991?
Keep it short and to the point. 0.98. What is the ratio of the Gross enrolment ratio (%) of Secondary schools in 1990 to that in 1991?
Give a very brief answer. 0.97. What is the ratio of the Gross enrolment ratio (%) of Tertiary schools in 1990 to that in 1991?
Keep it short and to the point. 0.96. What is the ratio of the Gross enrolment ratio (%) of Pre-primary schools in 1990 to that in 1992?
Your response must be concise. 0.95. What is the ratio of the Gross enrolment ratio (%) of Secondary schools in 1990 to that in 1992?
Your response must be concise. 0.98. What is the ratio of the Gross enrolment ratio (%) of Tertiary schools in 1990 to that in 1992?
Your response must be concise. 0.92. What is the ratio of the Gross enrolment ratio (%) in Pre-primary schools in 1990 to that in 1993?
Your answer should be very brief. 0.9. What is the ratio of the Gross enrolment ratio (%) in Primary schools in 1990 to that in 1993?
Give a very brief answer. 1.01. What is the ratio of the Gross enrolment ratio (%) in Secondary schools in 1990 to that in 1993?
Give a very brief answer. 0.96. What is the ratio of the Gross enrolment ratio (%) in Tertiary schools in 1990 to that in 1993?
Keep it short and to the point. 0.85. What is the ratio of the Gross enrolment ratio (%) of Pre-primary schools in 1990 to that in 1994?
Offer a terse response. 0.87. What is the ratio of the Gross enrolment ratio (%) in Primary schools in 1990 to that in 1994?
Keep it short and to the point. 1.03. What is the ratio of the Gross enrolment ratio (%) in Secondary schools in 1990 to that in 1994?
Make the answer very short. 0.94. What is the ratio of the Gross enrolment ratio (%) in Tertiary schools in 1990 to that in 1994?
Your answer should be compact. 0.76. What is the ratio of the Gross enrolment ratio (%) of Pre-primary schools in 1990 to that in 1995?
Offer a terse response. 0.86. What is the ratio of the Gross enrolment ratio (%) of Primary schools in 1990 to that in 1995?
Provide a succinct answer. 1.03. What is the ratio of the Gross enrolment ratio (%) in Secondary schools in 1990 to that in 1995?
Provide a succinct answer. 0.94. What is the ratio of the Gross enrolment ratio (%) in Tertiary schools in 1990 to that in 1995?
Provide a succinct answer. 0.74. What is the ratio of the Gross enrolment ratio (%) in Pre-primary schools in 1990 to that in 1996?
Make the answer very short. 0.84. What is the ratio of the Gross enrolment ratio (%) in Primary schools in 1990 to that in 1996?
Your answer should be compact. 1.03. What is the ratio of the Gross enrolment ratio (%) in Secondary schools in 1990 to that in 1996?
Make the answer very short. 0.95. What is the ratio of the Gross enrolment ratio (%) in Tertiary schools in 1990 to that in 1996?
Provide a short and direct response. 0.71. What is the ratio of the Gross enrolment ratio (%) of Pre-primary schools in 1991 to that in 1992?
Your response must be concise. 0.97. What is the ratio of the Gross enrolment ratio (%) in Primary schools in 1991 to that in 1992?
Offer a terse response. 0.99. What is the ratio of the Gross enrolment ratio (%) of Secondary schools in 1991 to that in 1992?
Ensure brevity in your answer.  1.01. What is the ratio of the Gross enrolment ratio (%) in Tertiary schools in 1991 to that in 1992?
Offer a terse response. 0.95. What is the ratio of the Gross enrolment ratio (%) of Pre-primary schools in 1991 to that in 1993?
Ensure brevity in your answer.  0.92. What is the ratio of the Gross enrolment ratio (%) in Primary schools in 1991 to that in 1993?
Your answer should be very brief. 1.01. What is the ratio of the Gross enrolment ratio (%) of Secondary schools in 1991 to that in 1993?
Keep it short and to the point. 0.99. What is the ratio of the Gross enrolment ratio (%) of Tertiary schools in 1991 to that in 1993?
Offer a terse response. 0.89. What is the ratio of the Gross enrolment ratio (%) in Pre-primary schools in 1991 to that in 1994?
Provide a succinct answer. 0.89. What is the ratio of the Gross enrolment ratio (%) of Primary schools in 1991 to that in 1994?
Your answer should be very brief. 1.03. What is the ratio of the Gross enrolment ratio (%) of Secondary schools in 1991 to that in 1994?
Provide a short and direct response. 0.97. What is the ratio of the Gross enrolment ratio (%) in Tertiary schools in 1991 to that in 1994?
Ensure brevity in your answer.  0.79. What is the ratio of the Gross enrolment ratio (%) of Pre-primary schools in 1991 to that in 1995?
Keep it short and to the point. 0.88. What is the ratio of the Gross enrolment ratio (%) in Primary schools in 1991 to that in 1995?
Offer a terse response. 1.03. What is the ratio of the Gross enrolment ratio (%) in Secondary schools in 1991 to that in 1995?
Offer a terse response. 0.96. What is the ratio of the Gross enrolment ratio (%) in Tertiary schools in 1991 to that in 1995?
Your answer should be compact. 0.77. What is the ratio of the Gross enrolment ratio (%) of Pre-primary schools in 1991 to that in 1996?
Your response must be concise. 0.86. What is the ratio of the Gross enrolment ratio (%) in Primary schools in 1991 to that in 1996?
Give a very brief answer. 1.03. What is the ratio of the Gross enrolment ratio (%) in Secondary schools in 1991 to that in 1996?
Offer a very short reply. 0.97. What is the ratio of the Gross enrolment ratio (%) in Tertiary schools in 1991 to that in 1996?
Offer a very short reply. 0.74. What is the ratio of the Gross enrolment ratio (%) of Pre-primary schools in 1992 to that in 1993?
Keep it short and to the point. 0.95. What is the ratio of the Gross enrolment ratio (%) of Primary schools in 1992 to that in 1993?
Your answer should be very brief. 1.02. What is the ratio of the Gross enrolment ratio (%) in Secondary schools in 1992 to that in 1993?
Your response must be concise. 0.98. What is the ratio of the Gross enrolment ratio (%) in Tertiary schools in 1992 to that in 1993?
Ensure brevity in your answer.  0.93. What is the ratio of the Gross enrolment ratio (%) of Pre-primary schools in 1992 to that in 1994?
Provide a short and direct response. 0.92. What is the ratio of the Gross enrolment ratio (%) in Primary schools in 1992 to that in 1994?
Provide a short and direct response. 1.04. What is the ratio of the Gross enrolment ratio (%) of Tertiary schools in 1992 to that in 1994?
Give a very brief answer. 0.83. What is the ratio of the Gross enrolment ratio (%) in Pre-primary schools in 1992 to that in 1995?
Offer a very short reply. 0.91. What is the ratio of the Gross enrolment ratio (%) in Primary schools in 1992 to that in 1995?
Your answer should be very brief. 1.04. What is the ratio of the Gross enrolment ratio (%) of Secondary schools in 1992 to that in 1995?
Ensure brevity in your answer.  0.96. What is the ratio of the Gross enrolment ratio (%) of Tertiary schools in 1992 to that in 1995?
Provide a succinct answer. 0.8. What is the ratio of the Gross enrolment ratio (%) of Pre-primary schools in 1992 to that in 1996?
Make the answer very short. 0.89. What is the ratio of the Gross enrolment ratio (%) in Primary schools in 1992 to that in 1996?
Offer a terse response. 1.04. What is the ratio of the Gross enrolment ratio (%) of Secondary schools in 1992 to that in 1996?
Offer a terse response. 0.97. What is the ratio of the Gross enrolment ratio (%) in Tertiary schools in 1992 to that in 1996?
Your answer should be very brief. 0.77. What is the ratio of the Gross enrolment ratio (%) of Pre-primary schools in 1993 to that in 1994?
Provide a succinct answer. 0.97. What is the ratio of the Gross enrolment ratio (%) of Primary schools in 1993 to that in 1994?
Provide a succinct answer. 1.02. What is the ratio of the Gross enrolment ratio (%) in Secondary schools in 1993 to that in 1994?
Ensure brevity in your answer.  0.98. What is the ratio of the Gross enrolment ratio (%) of Tertiary schools in 1993 to that in 1994?
Make the answer very short. 0.89. What is the ratio of the Gross enrolment ratio (%) of Pre-primary schools in 1993 to that in 1995?
Keep it short and to the point. 0.95. What is the ratio of the Gross enrolment ratio (%) of Primary schools in 1993 to that in 1995?
Your response must be concise. 1.02. What is the ratio of the Gross enrolment ratio (%) of Secondary schools in 1993 to that in 1995?
Ensure brevity in your answer.  0.97. What is the ratio of the Gross enrolment ratio (%) of Tertiary schools in 1993 to that in 1995?
Give a very brief answer. 0.86. What is the ratio of the Gross enrolment ratio (%) in Pre-primary schools in 1993 to that in 1996?
Give a very brief answer. 0.93. What is the ratio of the Gross enrolment ratio (%) of Primary schools in 1993 to that in 1996?
Offer a very short reply. 1.02. What is the ratio of the Gross enrolment ratio (%) of Secondary schools in 1993 to that in 1996?
Offer a terse response. 0.99. What is the ratio of the Gross enrolment ratio (%) of Tertiary schools in 1993 to that in 1996?
Offer a very short reply. 0.83. What is the ratio of the Gross enrolment ratio (%) in Pre-primary schools in 1994 to that in 1995?
Ensure brevity in your answer.  0.99. What is the ratio of the Gross enrolment ratio (%) of Secondary schools in 1994 to that in 1995?
Offer a very short reply. 1. What is the ratio of the Gross enrolment ratio (%) in Tertiary schools in 1994 to that in 1995?
Your answer should be compact. 0.97. What is the ratio of the Gross enrolment ratio (%) of Pre-primary schools in 1994 to that in 1996?
Your answer should be very brief. 0.97. What is the ratio of the Gross enrolment ratio (%) in Primary schools in 1994 to that in 1996?
Make the answer very short. 1. What is the ratio of the Gross enrolment ratio (%) in Secondary schools in 1994 to that in 1996?
Provide a short and direct response. 1.01. What is the ratio of the Gross enrolment ratio (%) in Tertiary schools in 1994 to that in 1996?
Your response must be concise. 0.94. What is the ratio of the Gross enrolment ratio (%) of Pre-primary schools in 1995 to that in 1996?
Keep it short and to the point. 0.98. What is the ratio of the Gross enrolment ratio (%) of Primary schools in 1995 to that in 1996?
Ensure brevity in your answer.  1. What is the ratio of the Gross enrolment ratio (%) of Secondary schools in 1995 to that in 1996?
Your response must be concise. 1.01. What is the ratio of the Gross enrolment ratio (%) of Tertiary schools in 1995 to that in 1996?
Ensure brevity in your answer.  0.96. What is the difference between the highest and the second highest Gross enrolment ratio (%) in Pre-primary schools?
Provide a short and direct response. 1.51. What is the difference between the highest and the second highest Gross enrolment ratio (%) of Primary schools?
Your response must be concise. 1.11. What is the difference between the highest and the second highest Gross enrolment ratio (%) in Secondary schools?
Give a very brief answer. 0.33. What is the difference between the highest and the second highest Gross enrolment ratio (%) of Tertiary schools?
Keep it short and to the point. 0.33. What is the difference between the highest and the lowest Gross enrolment ratio (%) in Pre-primary schools?
Provide a succinct answer. 11.36. What is the difference between the highest and the lowest Gross enrolment ratio (%) of Primary schools?
Provide a succinct answer. 3.93. What is the difference between the highest and the lowest Gross enrolment ratio (%) in Secondary schools?
Provide a short and direct response. 4.71. What is the difference between the highest and the lowest Gross enrolment ratio (%) of Tertiary schools?
Your answer should be compact. 2.62. 